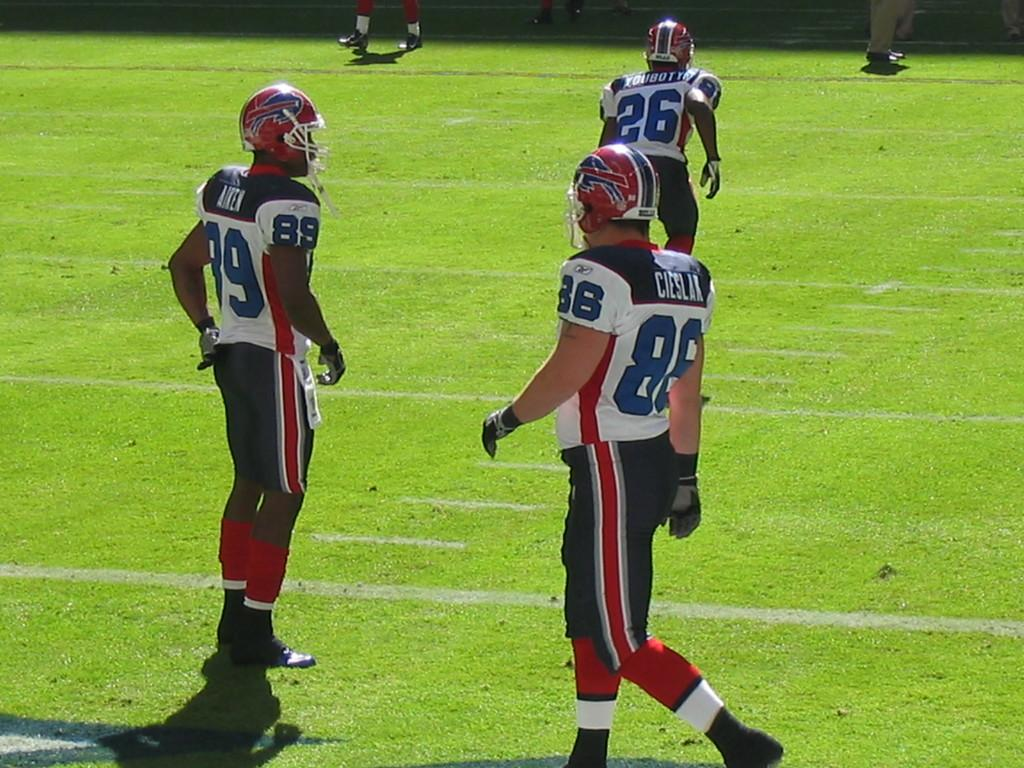How many people are in the image? There is a group of people in the image, but the exact number is not specified. What are the people standing on? The people are standing on the ground. What type of clothing are the people wearing? The people are wearing jerseys and helmets. How does the twist in the image affect the need for mouth protection? There is no twist mentioned in the image, and therefore it cannot affect the need for mouth protection. 